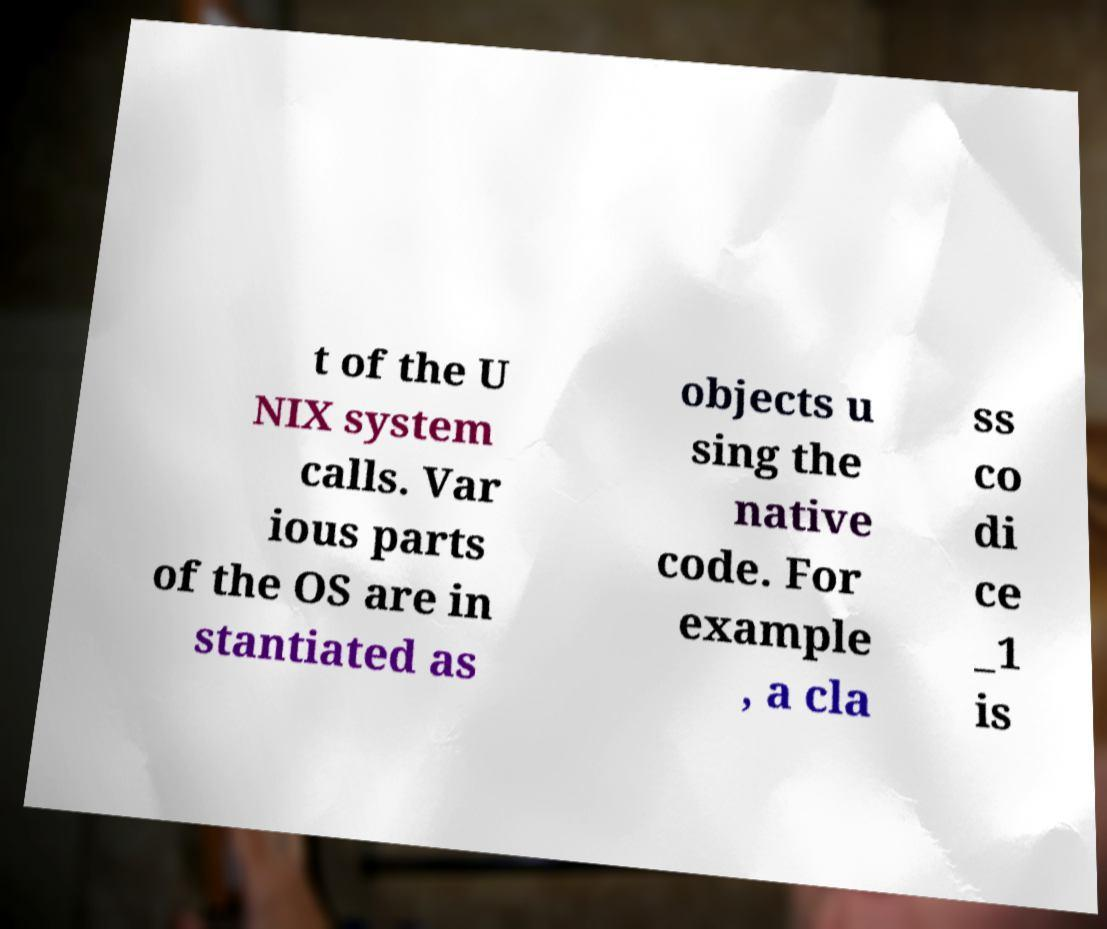I need the written content from this picture converted into text. Can you do that? t of the U NIX system calls. Var ious parts of the OS are in stantiated as objects u sing the native code. For example , a cla ss co di ce _1 is 